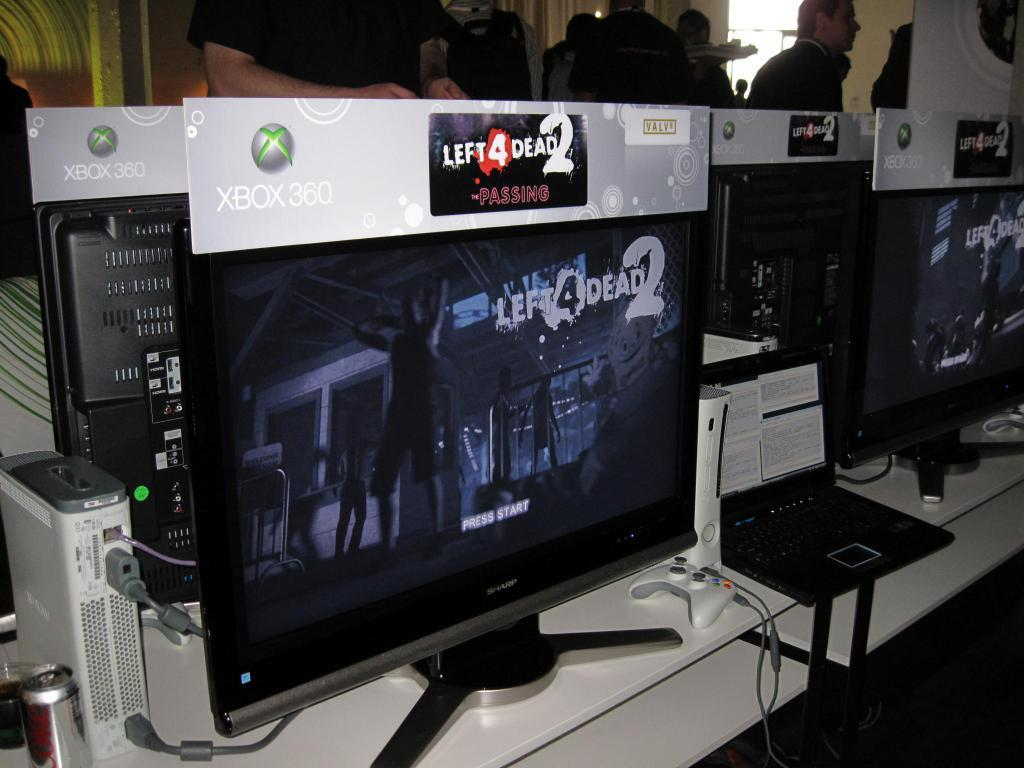<image>
Describe the image concisely. A computer monitor with XBox 360 Left 4 Dead 2 on the screen. 